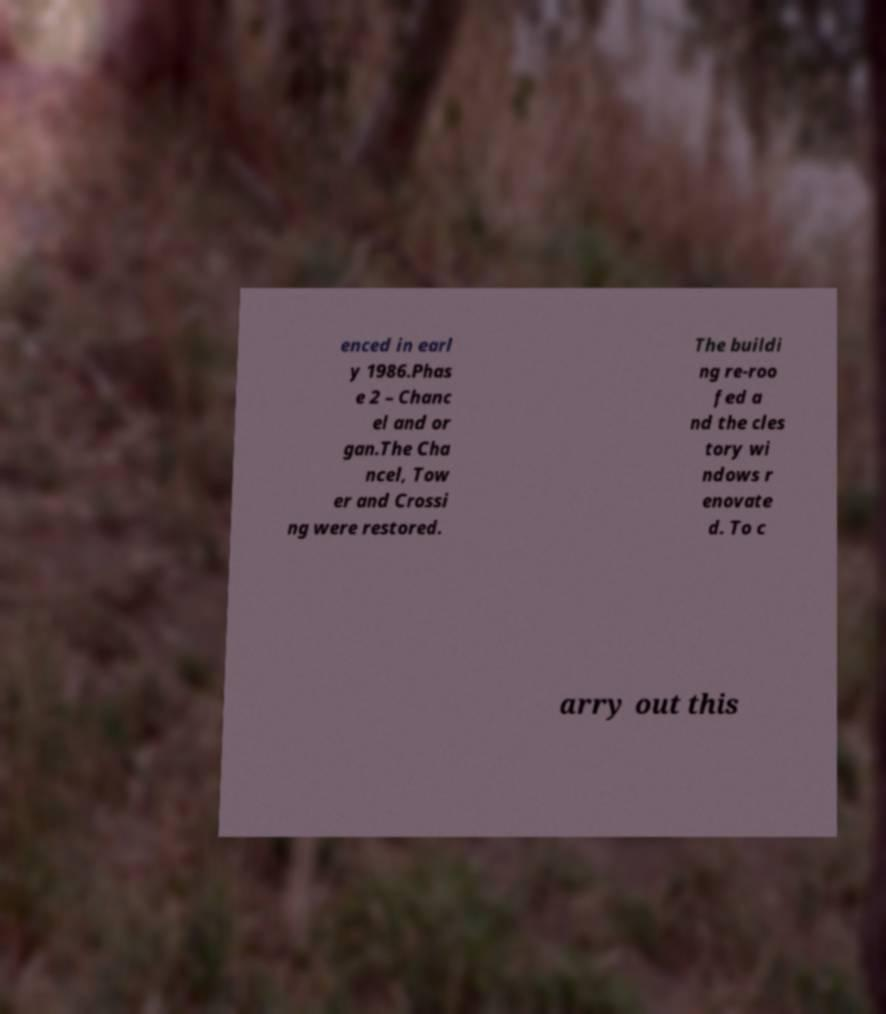Please read and relay the text visible in this image. What does it say? enced in earl y 1986.Phas e 2 – Chanc el and or gan.The Cha ncel, Tow er and Crossi ng were restored. The buildi ng re-roo fed a nd the cles tory wi ndows r enovate d. To c arry out this 